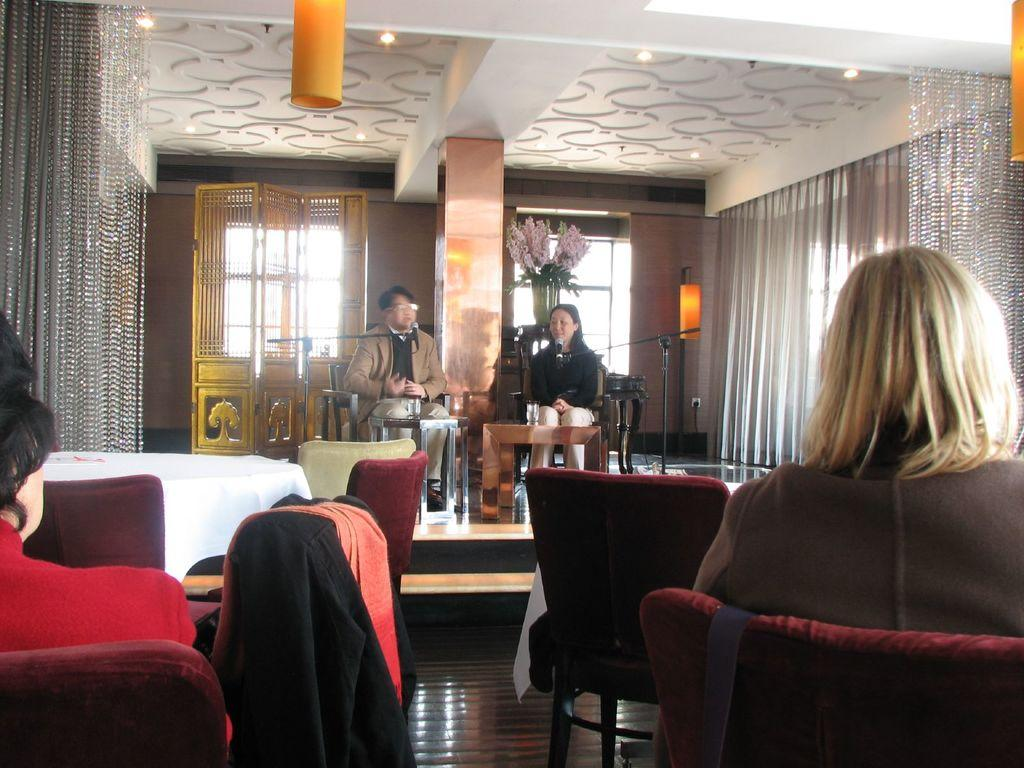What are the people in the room doing? There are people sitting on chairs in the room. What activity are two of the persons engaged in? Two persons are talking on a mic. What can be seen in the background of the room? There is a flower vase, a window, and a light in the background. How many people are in the crowd in the image? There is no crowd present in the image; it features people sitting on chairs in a room. Can you hear the person on the mic crying in the image? There is no indication of crying in the image, as it only shows people sitting on chairs and talking on a mic. 